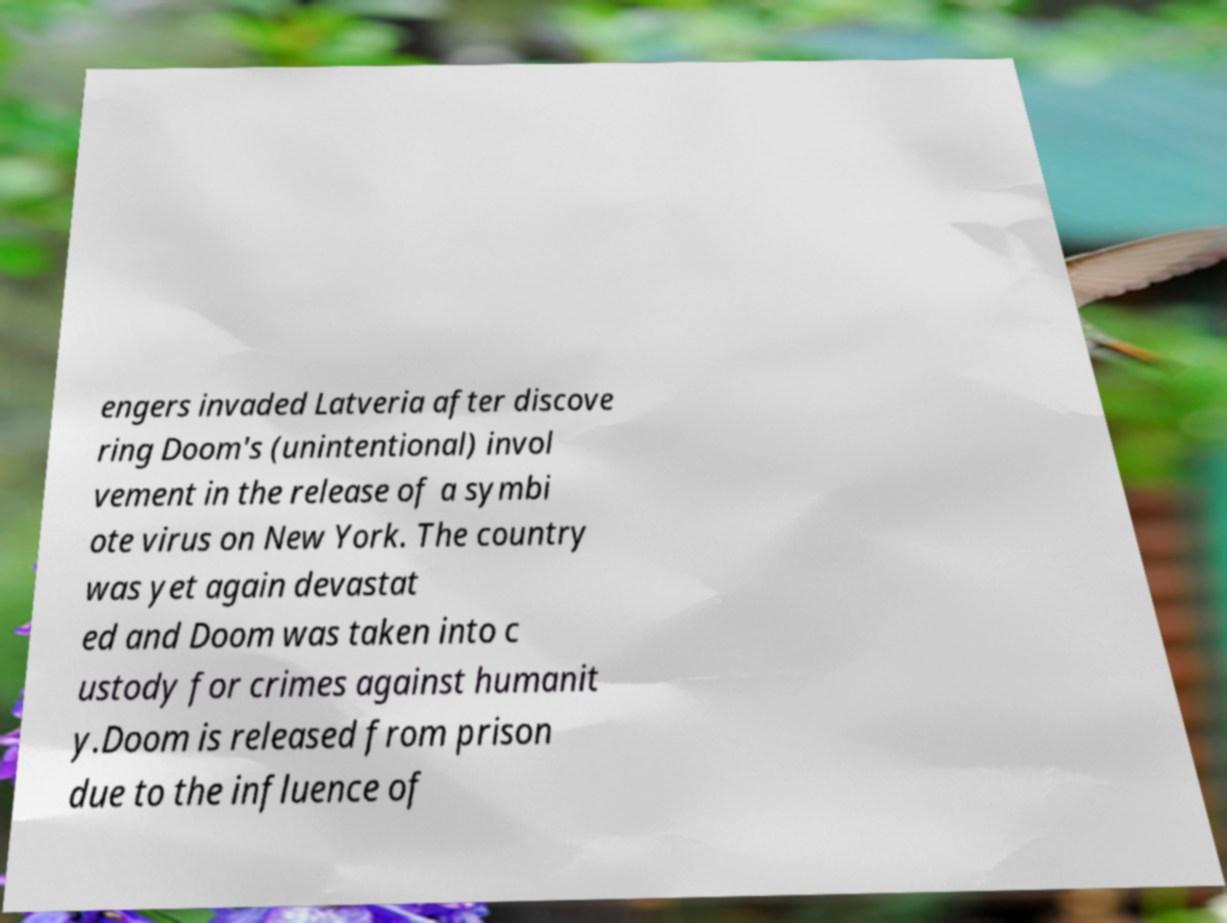Please identify and transcribe the text found in this image. engers invaded Latveria after discove ring Doom's (unintentional) invol vement in the release of a symbi ote virus on New York. The country was yet again devastat ed and Doom was taken into c ustody for crimes against humanit y.Doom is released from prison due to the influence of 